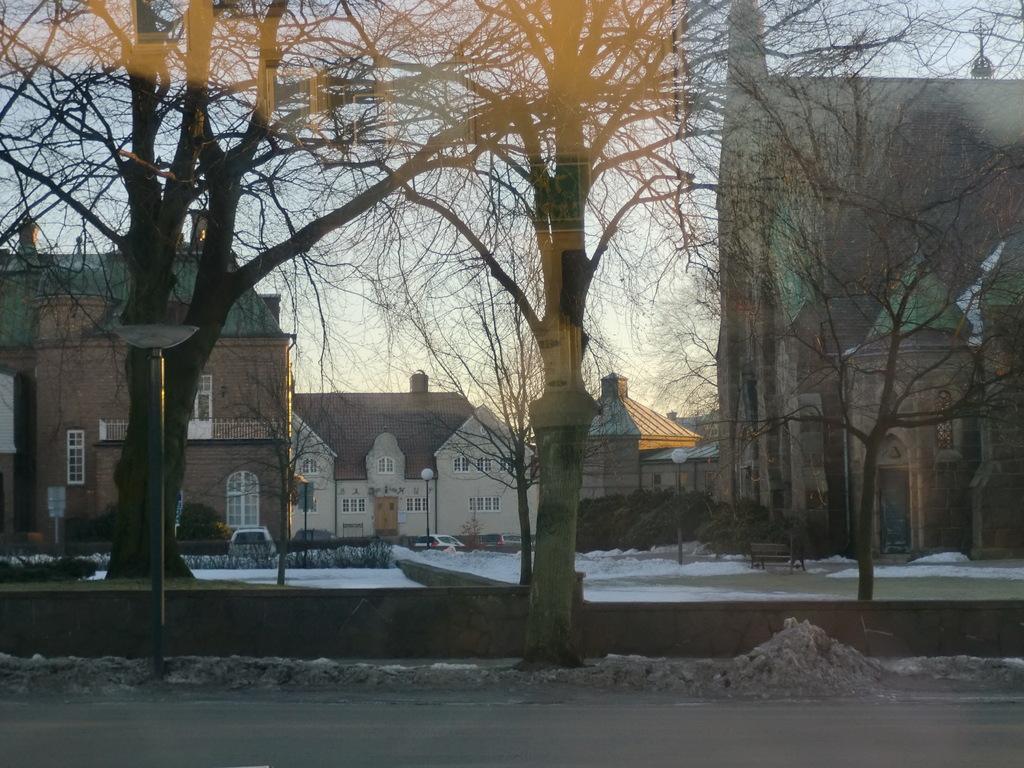Please provide a concise description of this image. In this picture I can see few buildings and trees and few pole lights and a bench and a car parked and a cloudy sky and I can see snow on the ground. 